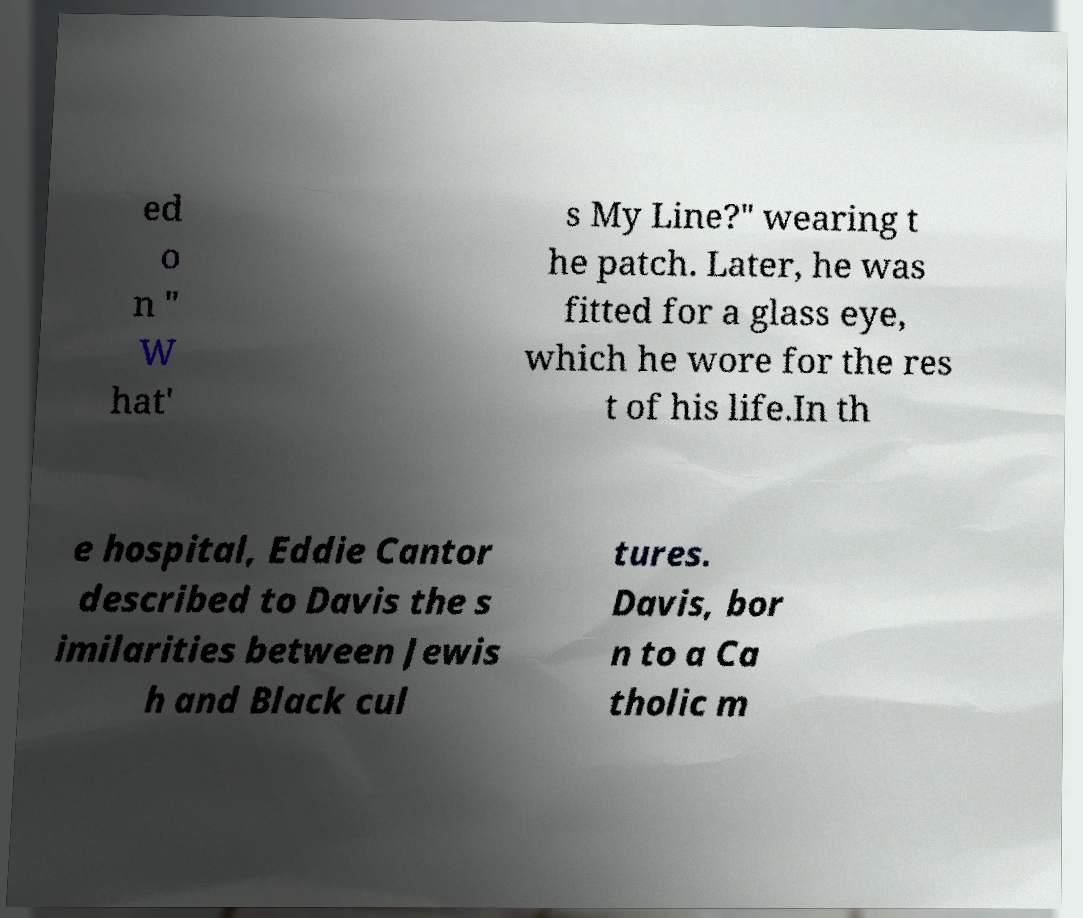Please read and relay the text visible in this image. What does it say? ed o n " W hat' s My Line?" wearing t he patch. Later, he was fitted for a glass eye, which he wore for the res t of his life.In th e hospital, Eddie Cantor described to Davis the s imilarities between Jewis h and Black cul tures. Davis, bor n to a Ca tholic m 